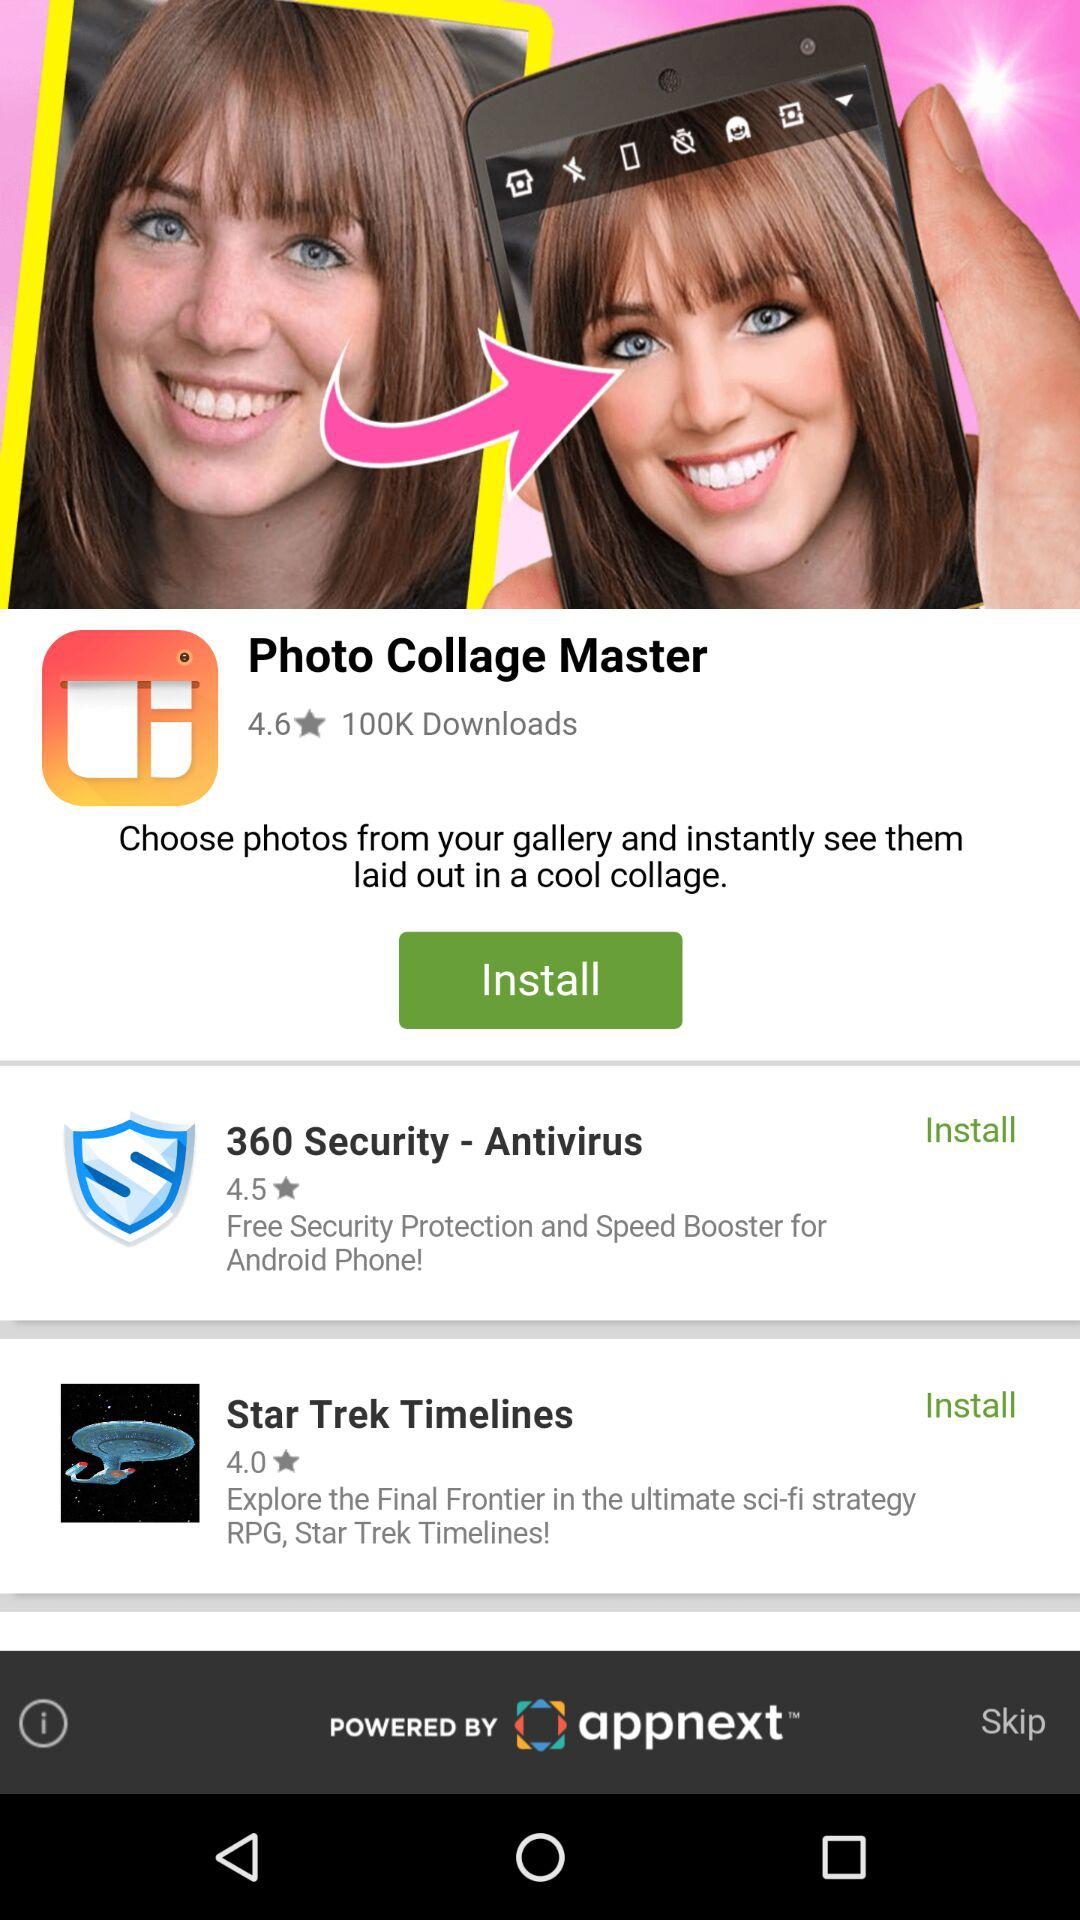How many ratings does "Star Trek Timelines" have? The rating is 4.0 stars. 